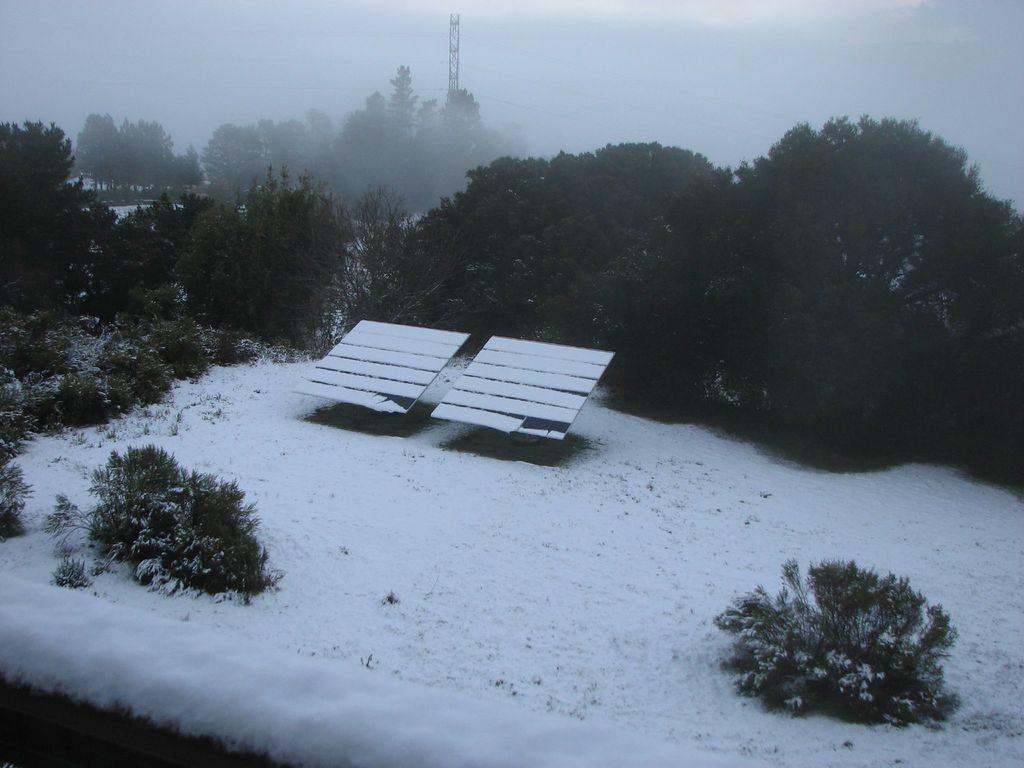Can you describe this image briefly? In the image we can see there is a ground which is covered with snow and there are two solar sheets kept on the ground. Behind there are lot of trees and there are plants on the ground. 